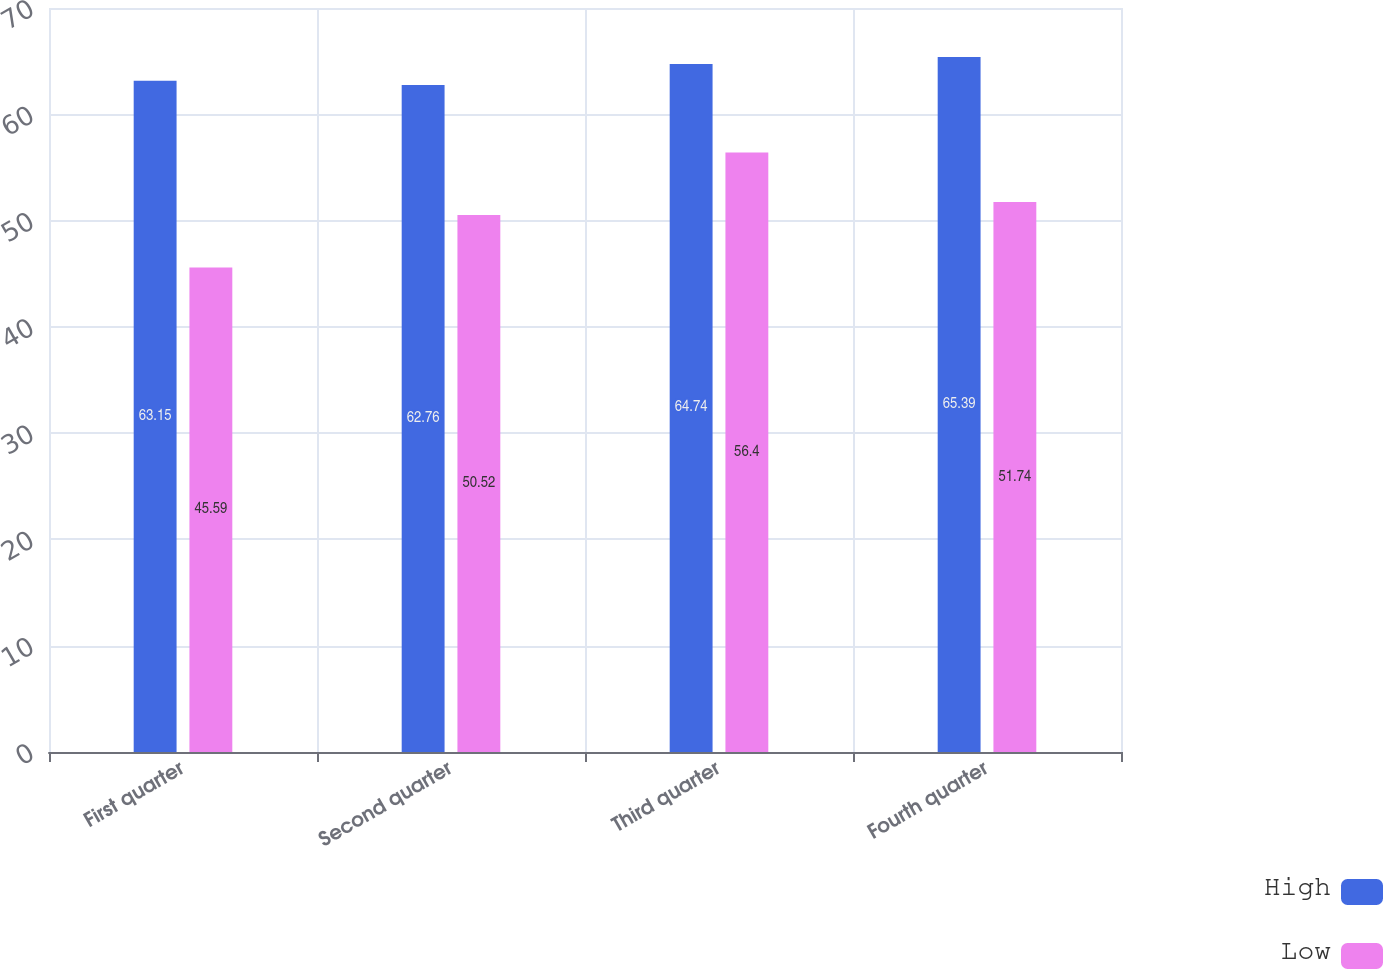Convert chart to OTSL. <chart><loc_0><loc_0><loc_500><loc_500><stacked_bar_chart><ecel><fcel>First quarter<fcel>Second quarter<fcel>Third quarter<fcel>Fourth quarter<nl><fcel>High<fcel>63.15<fcel>62.76<fcel>64.74<fcel>65.39<nl><fcel>Low<fcel>45.59<fcel>50.52<fcel>56.4<fcel>51.74<nl></chart> 